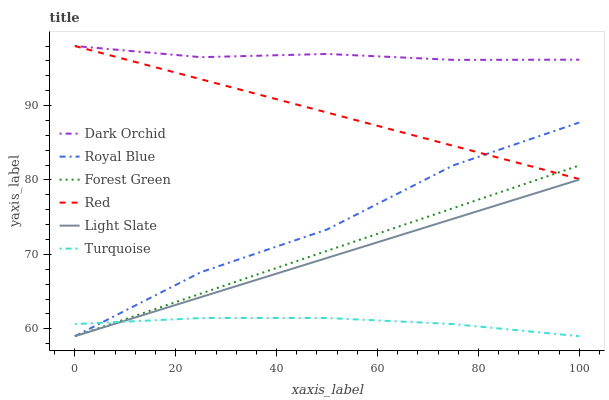Does Turquoise have the minimum area under the curve?
Answer yes or no. Yes. Does Dark Orchid have the maximum area under the curve?
Answer yes or no. Yes. Does Light Slate have the minimum area under the curve?
Answer yes or no. No. Does Light Slate have the maximum area under the curve?
Answer yes or no. No. Is Red the smoothest?
Answer yes or no. Yes. Is Royal Blue the roughest?
Answer yes or no. Yes. Is Light Slate the smoothest?
Answer yes or no. No. Is Light Slate the roughest?
Answer yes or no. No. Does Light Slate have the lowest value?
Answer yes or no. Yes. Does Dark Orchid have the lowest value?
Answer yes or no. No. Does Red have the highest value?
Answer yes or no. Yes. Does Light Slate have the highest value?
Answer yes or no. No. Is Turquoise less than Dark Orchid?
Answer yes or no. Yes. Is Dark Orchid greater than Turquoise?
Answer yes or no. Yes. Does Royal Blue intersect Light Slate?
Answer yes or no. Yes. Is Royal Blue less than Light Slate?
Answer yes or no. No. Is Royal Blue greater than Light Slate?
Answer yes or no. No. Does Turquoise intersect Dark Orchid?
Answer yes or no. No. 